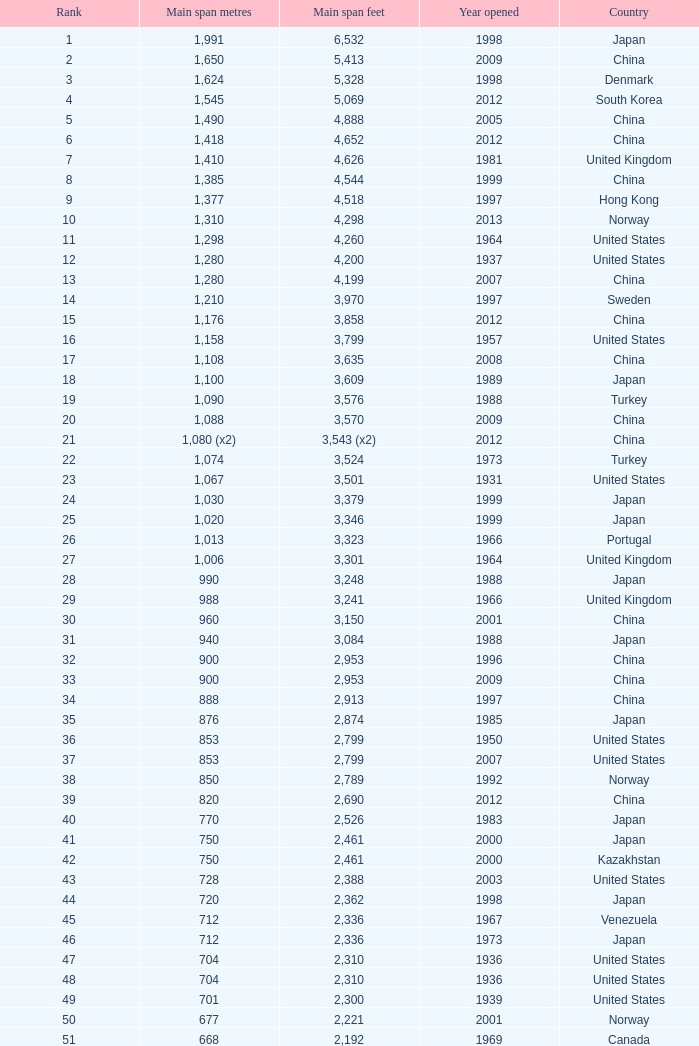Parse the full table. {'header': ['Rank', 'Main span metres', 'Main span feet', 'Year opened', 'Country'], 'rows': [['1', '1,991', '6,532', '1998', 'Japan'], ['2', '1,650', '5,413', '2009', 'China'], ['3', '1,624', '5,328', '1998', 'Denmark'], ['4', '1,545', '5,069', '2012', 'South Korea'], ['5', '1,490', '4,888', '2005', 'China'], ['6', '1,418', '4,652', '2012', 'China'], ['7', '1,410', '4,626', '1981', 'United Kingdom'], ['8', '1,385', '4,544', '1999', 'China'], ['9', '1,377', '4,518', '1997', 'Hong Kong'], ['10', '1,310', '4,298', '2013', 'Norway'], ['11', '1,298', '4,260', '1964', 'United States'], ['12', '1,280', '4,200', '1937', 'United States'], ['13', '1,280', '4,199', '2007', 'China'], ['14', '1,210', '3,970', '1997', 'Sweden'], ['15', '1,176', '3,858', '2012', 'China'], ['16', '1,158', '3,799', '1957', 'United States'], ['17', '1,108', '3,635', '2008', 'China'], ['18', '1,100', '3,609', '1989', 'Japan'], ['19', '1,090', '3,576', '1988', 'Turkey'], ['20', '1,088', '3,570', '2009', 'China'], ['21', '1,080 (x2)', '3,543 (x2)', '2012', 'China'], ['22', '1,074', '3,524', '1973', 'Turkey'], ['23', '1,067', '3,501', '1931', 'United States'], ['24', '1,030', '3,379', '1999', 'Japan'], ['25', '1,020', '3,346', '1999', 'Japan'], ['26', '1,013', '3,323', '1966', 'Portugal'], ['27', '1,006', '3,301', '1964', 'United Kingdom'], ['28', '990', '3,248', '1988', 'Japan'], ['29', '988', '3,241', '1966', 'United Kingdom'], ['30', '960', '3,150', '2001', 'China'], ['31', '940', '3,084', '1988', 'Japan'], ['32', '900', '2,953', '1996', 'China'], ['33', '900', '2,953', '2009', 'China'], ['34', '888', '2,913', '1997', 'China'], ['35', '876', '2,874', '1985', 'Japan'], ['36', '853', '2,799', '1950', 'United States'], ['37', '853', '2,799', '2007', 'United States'], ['38', '850', '2,789', '1992', 'Norway'], ['39', '820', '2,690', '2012', 'China'], ['40', '770', '2,526', '1983', 'Japan'], ['41', '750', '2,461', '2000', 'Japan'], ['42', '750', '2,461', '2000', 'Kazakhstan'], ['43', '728', '2,388', '2003', 'United States'], ['44', '720', '2,362', '1998', 'Japan'], ['45', '712', '2,336', '1967', 'Venezuela'], ['46', '712', '2,336', '1973', 'Japan'], ['47', '704', '2,310', '1936', 'United States'], ['48', '704', '2,310', '1936', 'United States'], ['49', '701', '2,300', '1939', 'United States'], ['50', '677', '2,221', '2001', 'Norway'], ['51', '668', '2,192', '1969', 'Canada'], ['52', '656', '2,152', '1968', 'United States'], ['53', '656', '2152', '1951', 'United States'], ['54', '648', '2,126', '1999', 'China'], ['55', '636', '2,087', '2009', 'China'], ['56', '623', '2,044', '1992', 'Norway'], ['57', '616', '2,021', '2009', 'China'], ['58', '610', '2,001', '1957', 'United States'], ['59', '608', '1,995', '1959', 'France'], ['60', '600', '1,969', '1970', 'Denmark'], ['61', '600', '1,969', '1999', 'Japan'], ['62', '600', '1,969', '2000', 'China'], ['63', '595', '1,952', '1997', 'Norway'], ['64', '580', '1,903', '2003', 'China'], ['65', '577', '1,893', '2001', 'Norway'], ['66', '570', '1,870', '1993', 'Japan'], ['67', '564', '1,850', '1929', 'United States Canada'], ['68', '560', '1,837', '1988', 'Japan'], ['69', '560', '1,837', '2001', 'China'], ['70', '549', '1,801', '1961', 'United States'], ['71', '540', '1,772', '2008', 'Japan'], ['72', '534', '1,752', '1926', 'United States'], ['73', '525', '1,722', '1972', 'Norway'], ['74', '525', '1,722', '1977', 'Norway'], ['75', '520', '1,706', '1983', 'Democratic Republic of the Congo'], ['76', '500', '1,640', '1965', 'Germany'], ['77', '500', '1,640', '2002', 'South Korea'], ['78', '497', '1,631', '1924', 'United States'], ['79', '488', '1,601', '1903', 'United States'], ['80', '488', '1,601', '1969', 'United States'], ['81', '488', '1,601', '1952', 'United States'], ['82', '488', '1,601', '1973', 'United States'], ['83', '486', '1,594', '1883', 'United States'], ['84', '473', '1,552', '1938', 'Canada'], ['85', '468', '1,535', '1971', 'Norway'], ['86', '465', '1,526', '1977', 'Japan'], ['87', '457', '1,499', '1930', 'United States'], ['88', '457', '1,499', '1963', 'United States'], ['89', '452', '1,483', '1995', 'China'], ['90', '450', '1,476', '1997', 'China'], ['91', '448', '1,470', '1909', 'United States'], ['92', '446', '1,463', '1997', 'Norway'], ['93', '441', '1,447', '1955', 'Canada'], ['94', '430', '1,411', '2012', 'China'], ['95', '427', '1,401', '1970', 'Canada'], ['96', '421', '1,381', '1936', 'United States'], ['97', '417', '1,368', '1966', 'Sweden'], ['98', '408', '1339', '2010', 'China'], ['99', '405', '1,329', '2009', 'Vietnam'], ['100', '404', '1,325', '1973', 'South Korea'], ['101', '394', '1,293', '1967', 'France'], ['102', '390', '1,280', '1964', 'Uzbekistan'], ['103', '385', '1,263', '2013', 'United States'], ['104', '378', '1,240', '1954', 'Germany'], ['105', '368', '1,207', '1931', 'United States'], ['106', '367', '1,204', '1962', 'Japan'], ['107', '366', '1,200', '1929', 'United States'], ['108', '351', '1,151', '1960', 'United States Canada'], ['109', '350', '1,148', '2006', 'China'], ['110', '340', '1,115', '1926', 'Brazil'], ['111', '338', '1,109', '2001', 'China'], ['112', '338', '1,108', '1965', 'United States'], ['113', '337', '1,106', '1956', 'Norway'], ['114', '335', '1,100', '1961', 'United Kingdom'], ['115', '335', '1,100', '2006', 'Norway'], ['116', '329', '1,088', '1939', 'United States'], ['117', '328', '1,085', '1939', 'Zambia Zimbabwe'], ['118', '325', '1,066', '1964', 'Norway'], ['119', '325', '1,066', '1981', 'Norway'], ['120', '323', '1,060', '1932', 'United States'], ['121', '323', '1,059', '1936', 'Canada'], ['122', '322', '1,057', '1867', 'United States'], ['123', '320', '1,050', '1971', 'United States'], ['124', '320', '1,050', '2011', 'Peru'], ['125', '315', '1,033', '1951', 'Germany'], ['126', '308', '1,010', '1849', 'United States'], ['127', '300', '985', '1961', 'Canada'], ['128', '300', '984', '1987', 'Japan'], ['129', '300', '984', '2000', 'France'], ['130', '300', '984', '2000', 'South Korea']]} What is the earliest year with a primary span length of 1,640 feet in south korea? 2002.0. 